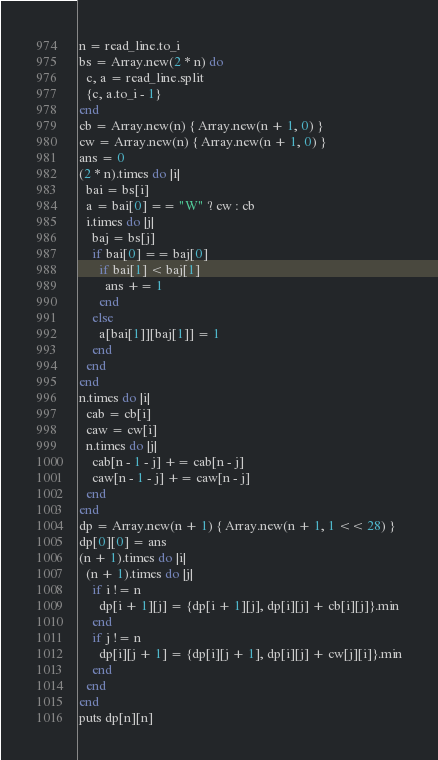<code> <loc_0><loc_0><loc_500><loc_500><_Crystal_>n = read_line.to_i
bs = Array.new(2 * n) do
  c, a = read_line.split
  {c, a.to_i - 1}
end
cb = Array.new(n) { Array.new(n + 1, 0) }
cw = Array.new(n) { Array.new(n + 1, 0) }
ans = 0
(2 * n).times do |i|
  bai = bs[i]
  a = bai[0] == "W" ? cw : cb
  i.times do |j|
    baj = bs[j]
    if bai[0] == baj[0]
      if bai[1] < baj[1]
        ans += 1
      end
    else
      a[bai[1]][baj[1]] = 1
    end
  end
end
n.times do |i|
  cab = cb[i]
  caw = cw[i]
  n.times do |j|
    cab[n - 1 - j] += cab[n - j]
    caw[n - 1 - j] += caw[n - j]
  end
end
dp = Array.new(n + 1) { Array.new(n + 1, 1 << 28) }
dp[0][0] = ans
(n + 1).times do |i|
  (n + 1).times do |j|
    if i != n
      dp[i + 1][j] = {dp[i + 1][j], dp[i][j] + cb[i][j]}.min
    end
    if j != n
      dp[i][j + 1] = {dp[i][j + 1], dp[i][j] + cw[j][i]}.min
    end
  end
end
puts dp[n][n]
</code> 